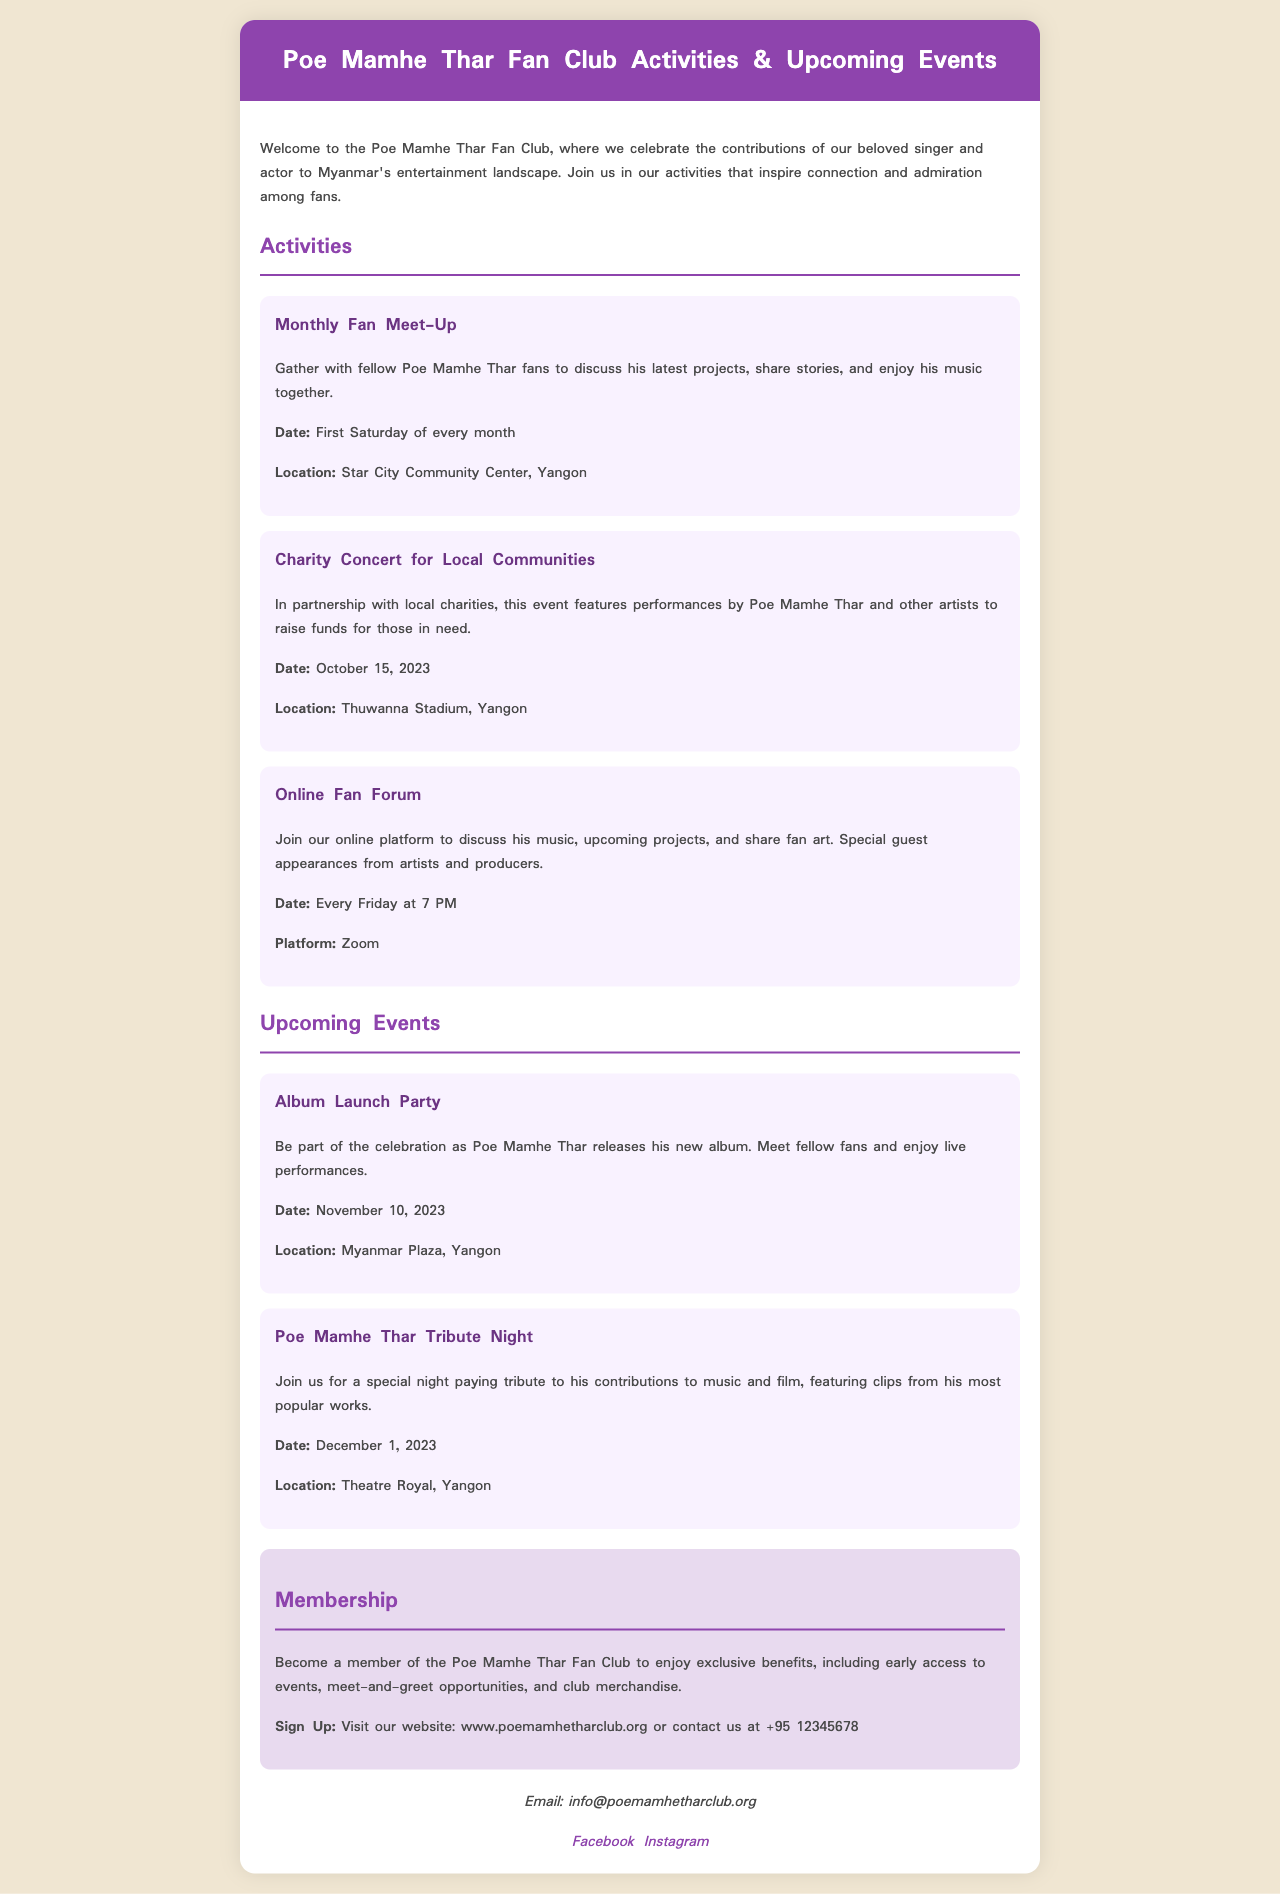What is the date of the Monthly Fan Meet-Up? The Monthly Fan Meet-Up occurs on the First Saturday of every month as mentioned in the activities section.
Answer: First Saturday of every month Where will the Charity Concert for Local Communities take place? The location specified for the Charity Concert is Thuwanna Stadium, Yangon, as provided in the activities section.
Answer: Thuwanna Stadium, Yangon What is the date for the Album Launch Party? The Album Launch Party is scheduled for November 10, 2023, based on the upcoming events listed.
Answer: November 10, 2023 What type of events does the Poe Mamhe Thar Fan Club organize? The brochure details activities like a Monthly Fan Meet-Up and a Charity Concert, indicating a focus on community engagement and celebration of the artist.
Answer: Community engagement and celebration How can one become a member of the Poe Mamhe Thar Fan Club? The process to become a member involves visiting their website or contacting them, as written in the membership section.
Answer: Visit the website or contact us What is the email address for the Poe Mamhe Thar Fan Club? The email address listed for contact is info@poemamhetharclub.org, which is found in the contact section.
Answer: info@poemamhetharclub.org When is the Poe Mamhe Thar Tribute Night scheduled? The Tribute Night is listed to occur on December 1, 2023, in the upcoming events portion of the document.
Answer: December 1, 2023 What platform hosts the Online Fan Forum? The Online Fan Forum is hosted on Zoom, as per the description of the online activities.
Answer: Zoom 